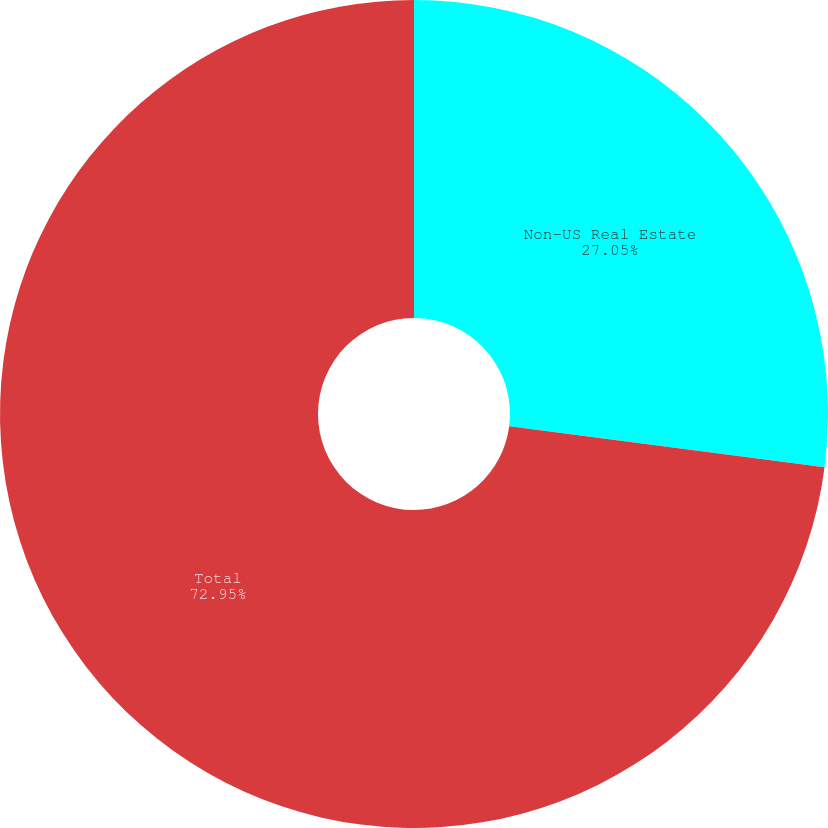Convert chart. <chart><loc_0><loc_0><loc_500><loc_500><pie_chart><fcel>Non-US Real Estate<fcel>Total<nl><fcel>27.05%<fcel>72.95%<nl></chart> 